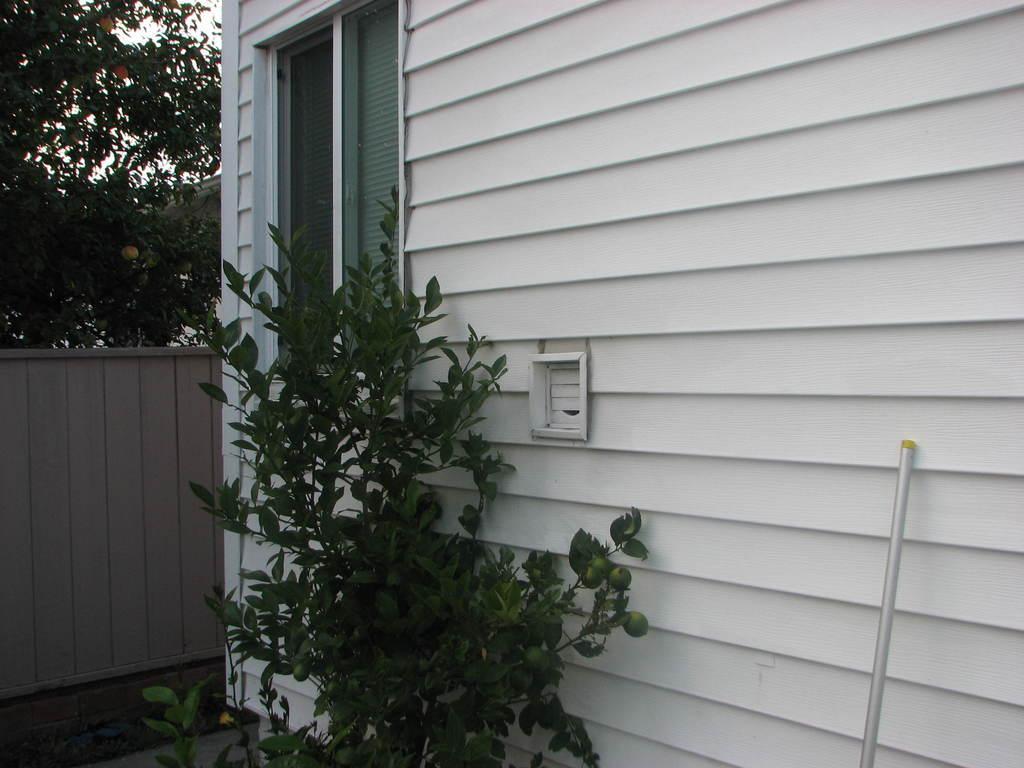How would you summarize this image in a sentence or two? In this image we can see a house. There is a plant and tree in the image. There is an object at the right side of the image. 